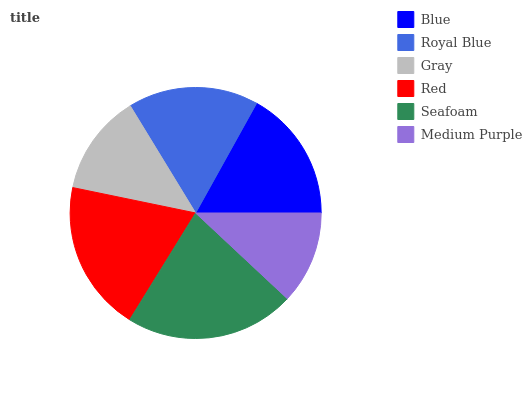Is Medium Purple the minimum?
Answer yes or no. Yes. Is Seafoam the maximum?
Answer yes or no. Yes. Is Royal Blue the minimum?
Answer yes or no. No. Is Royal Blue the maximum?
Answer yes or no. No. Is Blue greater than Royal Blue?
Answer yes or no. Yes. Is Royal Blue less than Blue?
Answer yes or no. Yes. Is Royal Blue greater than Blue?
Answer yes or no. No. Is Blue less than Royal Blue?
Answer yes or no. No. Is Blue the high median?
Answer yes or no. Yes. Is Royal Blue the low median?
Answer yes or no. Yes. Is Royal Blue the high median?
Answer yes or no. No. Is Medium Purple the low median?
Answer yes or no. No. 